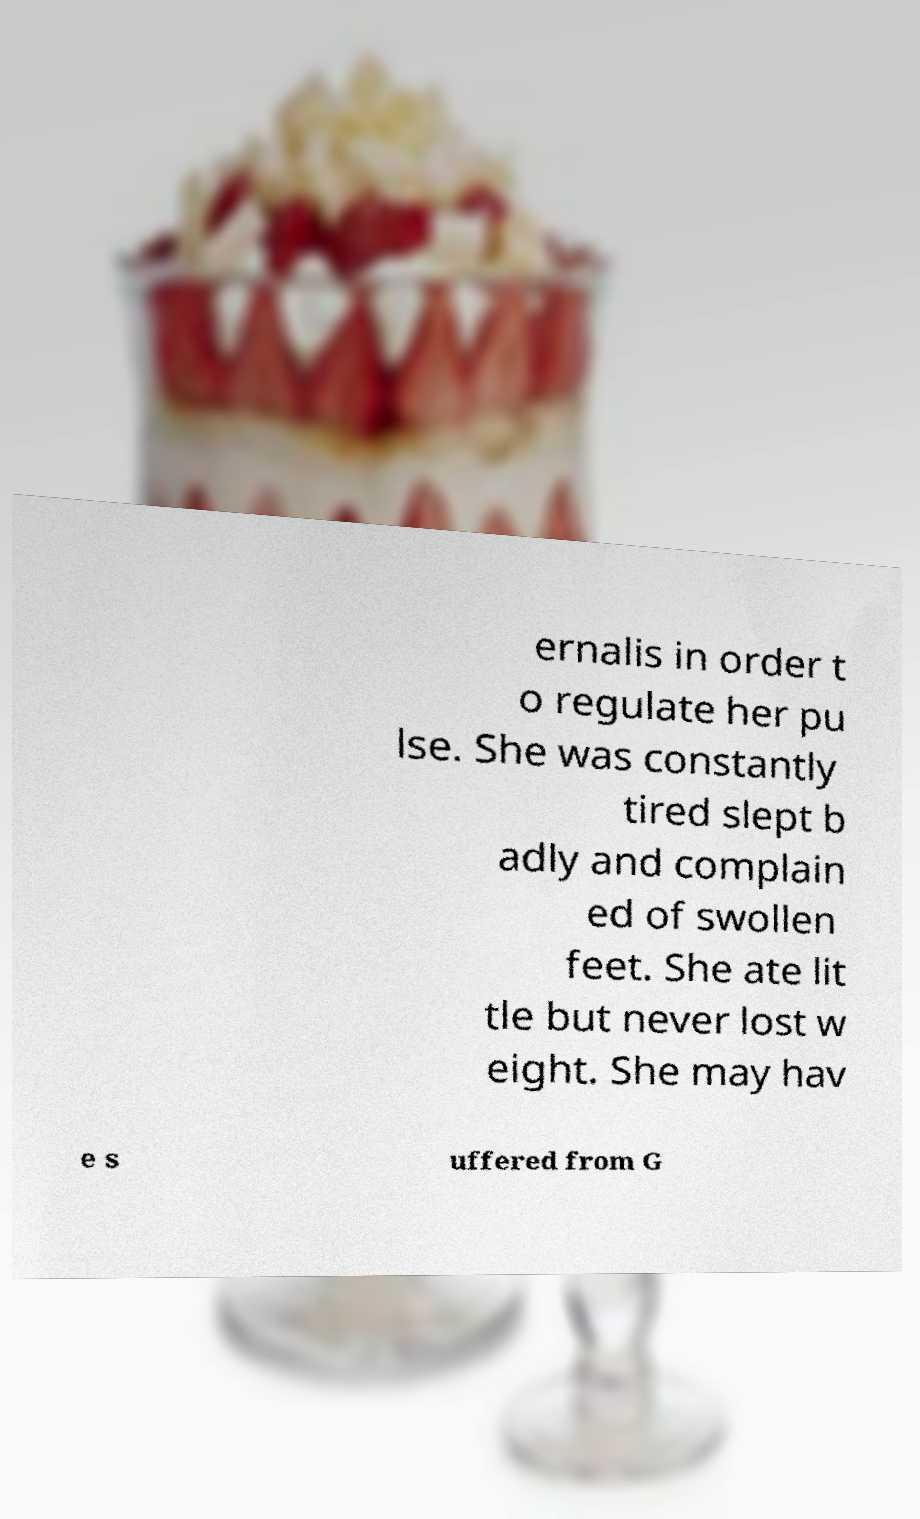There's text embedded in this image that I need extracted. Can you transcribe it verbatim? ernalis in order t o regulate her pu lse. She was constantly tired slept b adly and complain ed of swollen feet. She ate lit tle but never lost w eight. She may hav e s uffered from G 